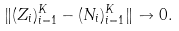<formula> <loc_0><loc_0><loc_500><loc_500>\| ( Z _ { i } ) _ { i = 1 } ^ { K } - ( N _ { i } ) _ { i = 1 } ^ { K } \| \to 0 .</formula> 